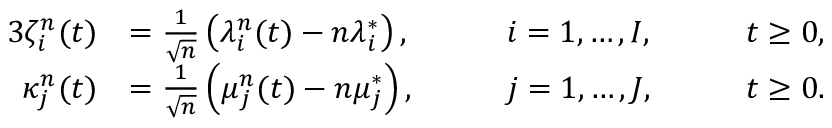<formula> <loc_0><loc_0><loc_500><loc_500>\begin{array} { r l r l r l } { { 3 } \zeta _ { i } ^ { n } ( t ) } & { = \frac { 1 } { \sqrt { n } } \left ( \lambda _ { i } ^ { n } ( t ) - n \lambda _ { i } ^ { * } \right ) , } & & { \quad i = 1 , \dots , I , } & & { \quad t \geq 0 , } \\ { \kappa _ { j } ^ { n } ( t ) } & { = \frac { 1 } { \sqrt { n } } \left ( \mu _ { j } ^ { n } ( t ) - n \mu _ { j } ^ { * } \right ) , } & & { \quad j = 1 , \dots , J , } & & { \quad t \geq 0 . } \end{array}</formula> 